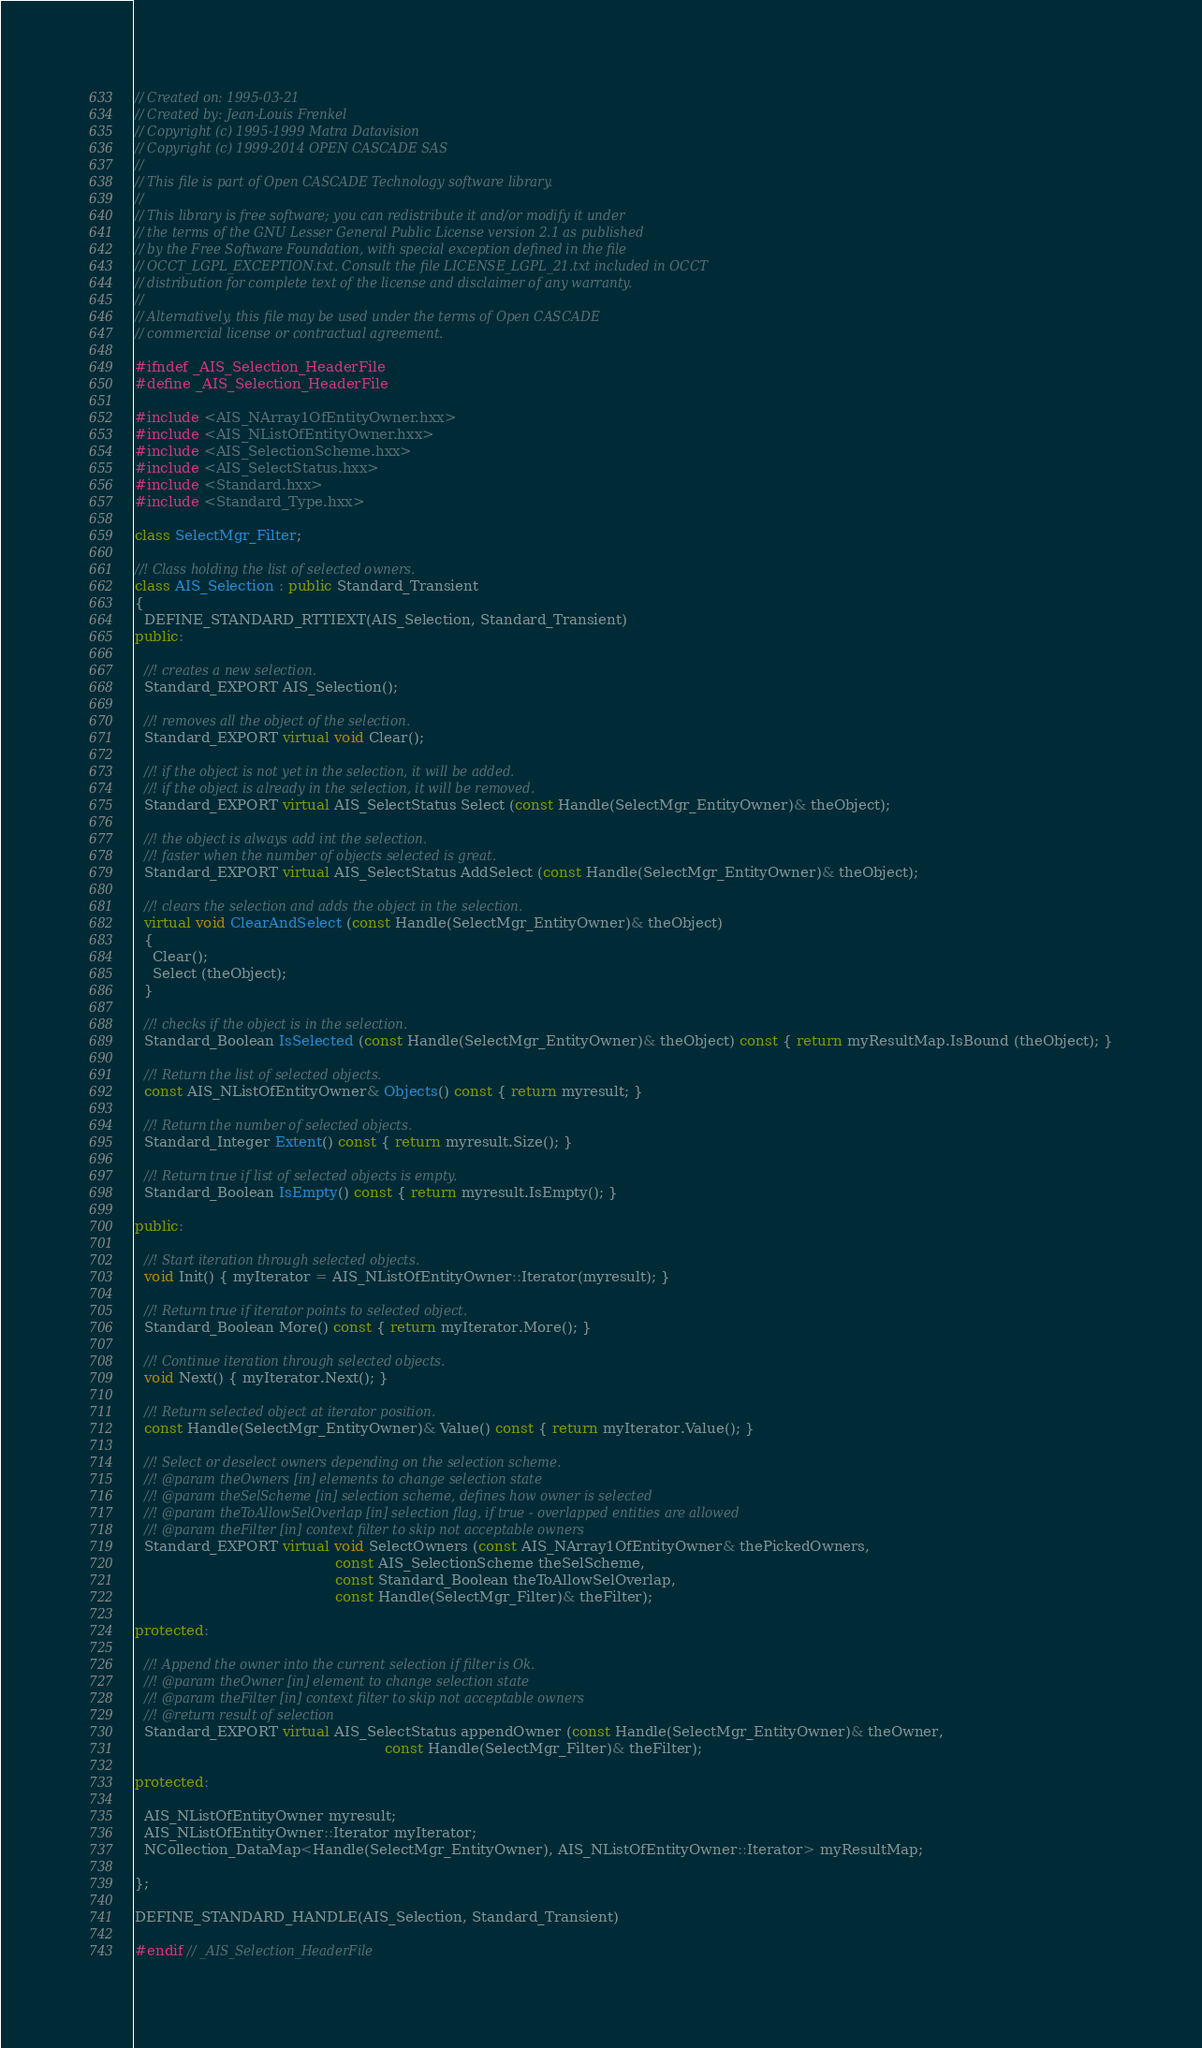<code> <loc_0><loc_0><loc_500><loc_500><_C++_>// Created on: 1995-03-21
// Created by: Jean-Louis Frenkel
// Copyright (c) 1995-1999 Matra Datavision
// Copyright (c) 1999-2014 OPEN CASCADE SAS
//
// This file is part of Open CASCADE Technology software library.
//
// This library is free software; you can redistribute it and/or modify it under
// the terms of the GNU Lesser General Public License version 2.1 as published
// by the Free Software Foundation, with special exception defined in the file
// OCCT_LGPL_EXCEPTION.txt. Consult the file LICENSE_LGPL_21.txt included in OCCT
// distribution for complete text of the license and disclaimer of any warranty.
//
// Alternatively, this file may be used under the terms of Open CASCADE
// commercial license or contractual agreement.

#ifndef _AIS_Selection_HeaderFile
#define _AIS_Selection_HeaderFile

#include <AIS_NArray1OfEntityOwner.hxx>
#include <AIS_NListOfEntityOwner.hxx>
#include <AIS_SelectionScheme.hxx>
#include <AIS_SelectStatus.hxx>
#include <Standard.hxx>
#include <Standard_Type.hxx>

class SelectMgr_Filter;

//! Class holding the list of selected owners.
class AIS_Selection : public Standard_Transient
{
  DEFINE_STANDARD_RTTIEXT(AIS_Selection, Standard_Transient)
public:

  //! creates a new selection.
  Standard_EXPORT AIS_Selection();
  
  //! removes all the object of the selection.
  Standard_EXPORT virtual void Clear();
  
  //! if the object is not yet in the selection, it will be added.
  //! if the object is already in the selection, it will be removed.
  Standard_EXPORT virtual AIS_SelectStatus Select (const Handle(SelectMgr_EntityOwner)& theObject);
  
  //! the object is always add int the selection.
  //! faster when the number of objects selected is great.
  Standard_EXPORT virtual AIS_SelectStatus AddSelect (const Handle(SelectMgr_EntityOwner)& theObject);

  //! clears the selection and adds the object in the selection.
  virtual void ClearAndSelect (const Handle(SelectMgr_EntityOwner)& theObject)
  {
    Clear();
    Select (theObject);
  }

  //! checks if the object is in the selection.
  Standard_Boolean IsSelected (const Handle(SelectMgr_EntityOwner)& theObject) const { return myResultMap.IsBound (theObject); }

  //! Return the list of selected objects.
  const AIS_NListOfEntityOwner& Objects() const { return myresult; }

  //! Return the number of selected objects.
  Standard_Integer Extent() const { return myresult.Size(); }

  //! Return true if list of selected objects is empty.
  Standard_Boolean IsEmpty() const { return myresult.IsEmpty(); }

public:

  //! Start iteration through selected objects.
  void Init() { myIterator = AIS_NListOfEntityOwner::Iterator(myresult); }

  //! Return true if iterator points to selected object.
  Standard_Boolean More() const { return myIterator.More(); }

  //! Continue iteration through selected objects.
  void Next() { myIterator.Next(); }

  //! Return selected object at iterator position.
  const Handle(SelectMgr_EntityOwner)& Value() const { return myIterator.Value(); }

  //! Select or deselect owners depending on the selection scheme.
  //! @param theOwners [in] elements to change selection state
  //! @param theSelScheme [in] selection scheme, defines how owner is selected
  //! @param theToAllowSelOverlap [in] selection flag, if true - overlapped entities are allowed
  //! @param theFilter [in] context filter to skip not acceptable owners
  Standard_EXPORT virtual void SelectOwners (const AIS_NArray1OfEntityOwner& thePickedOwners,
                                             const AIS_SelectionScheme theSelScheme,
                                             const Standard_Boolean theToAllowSelOverlap,
                                             const Handle(SelectMgr_Filter)& theFilter);

protected:

  //! Append the owner into the current selection if filter is Ok.
  //! @param theOwner [in] element to change selection state
  //! @param theFilter [in] context filter to skip not acceptable owners
  //! @return result of selection
  Standard_EXPORT virtual AIS_SelectStatus appendOwner (const Handle(SelectMgr_EntityOwner)& theOwner,
                                                        const Handle(SelectMgr_Filter)& theFilter);

protected:

  AIS_NListOfEntityOwner myresult;
  AIS_NListOfEntityOwner::Iterator myIterator;
  NCollection_DataMap<Handle(SelectMgr_EntityOwner), AIS_NListOfEntityOwner::Iterator> myResultMap;

};

DEFINE_STANDARD_HANDLE(AIS_Selection, Standard_Transient)

#endif // _AIS_Selection_HeaderFile
</code> 